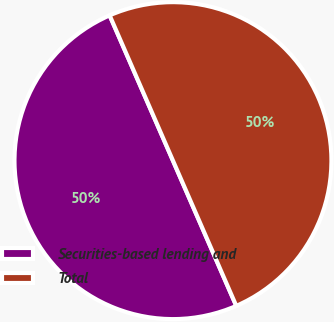<chart> <loc_0><loc_0><loc_500><loc_500><pie_chart><fcel>Securities-based lending and<fcel>Total<nl><fcel>50.0%<fcel>50.0%<nl></chart> 